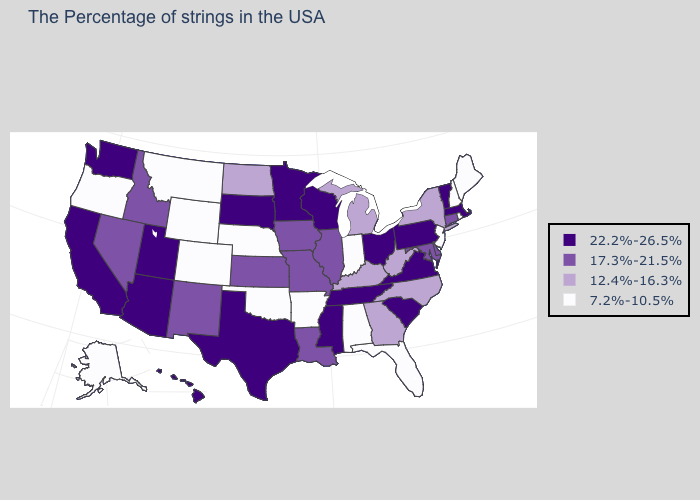What is the highest value in the USA?
Answer briefly. 22.2%-26.5%. Does Georgia have a lower value than Vermont?
Concise answer only. Yes. What is the value of Vermont?
Short answer required. 22.2%-26.5%. Does Colorado have the highest value in the USA?
Short answer required. No. Which states have the lowest value in the USA?
Short answer required. Maine, Rhode Island, New Hampshire, New Jersey, Florida, Indiana, Alabama, Arkansas, Nebraska, Oklahoma, Wyoming, Colorado, Montana, Oregon, Alaska. What is the lowest value in the USA?
Quick response, please. 7.2%-10.5%. Does the first symbol in the legend represent the smallest category?
Concise answer only. No. Name the states that have a value in the range 12.4%-16.3%?
Concise answer only. New York, North Carolina, West Virginia, Georgia, Michigan, Kentucky, North Dakota. Which states hav the highest value in the MidWest?
Quick response, please. Ohio, Wisconsin, Minnesota, South Dakota. Does the first symbol in the legend represent the smallest category?
Answer briefly. No. What is the highest value in the MidWest ?
Answer briefly. 22.2%-26.5%. Which states have the highest value in the USA?
Concise answer only. Massachusetts, Vermont, Pennsylvania, Virginia, South Carolina, Ohio, Tennessee, Wisconsin, Mississippi, Minnesota, Texas, South Dakota, Utah, Arizona, California, Washington, Hawaii. Which states have the lowest value in the USA?
Concise answer only. Maine, Rhode Island, New Hampshire, New Jersey, Florida, Indiana, Alabama, Arkansas, Nebraska, Oklahoma, Wyoming, Colorado, Montana, Oregon, Alaska. Which states have the highest value in the USA?
Be succinct. Massachusetts, Vermont, Pennsylvania, Virginia, South Carolina, Ohio, Tennessee, Wisconsin, Mississippi, Minnesota, Texas, South Dakota, Utah, Arizona, California, Washington, Hawaii. What is the highest value in the South ?
Answer briefly. 22.2%-26.5%. 